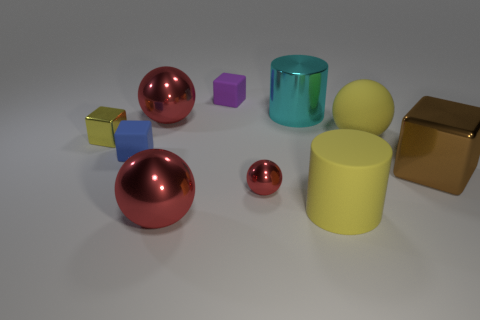Is the color of the tiny metallic thing left of the small purple matte cube the same as the cylinder in front of the brown metal cube?
Give a very brief answer. Yes. There is a tiny blue rubber block; are there any small objects behind it?
Your response must be concise. Yes. There is a red thing that is on the left side of the purple object and in front of the yellow block; what material is it?
Provide a short and direct response. Metal. Is the red sphere behind the small metal block made of the same material as the small yellow cube?
Your response must be concise. Yes. What is the small purple block made of?
Make the answer very short. Rubber. What size is the yellow object to the left of the small blue cube?
Your answer should be compact. Small. Is there any other thing that is the same color as the large metal cylinder?
Your answer should be compact. No. There is a big yellow object right of the large cylinder that is in front of the large cyan cylinder; are there any big cylinders behind it?
Keep it short and to the point. Yes. Do the cylinder in front of the blue rubber object and the big rubber ball have the same color?
Your answer should be compact. Yes. How many cubes are either small gray matte objects or blue things?
Your answer should be very brief. 1. 